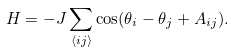Convert formula to latex. <formula><loc_0><loc_0><loc_500><loc_500>H = - J \sum _ { \left < i j \right > } \cos ( \theta _ { i } - \theta _ { j } + A _ { i j } ) .</formula> 